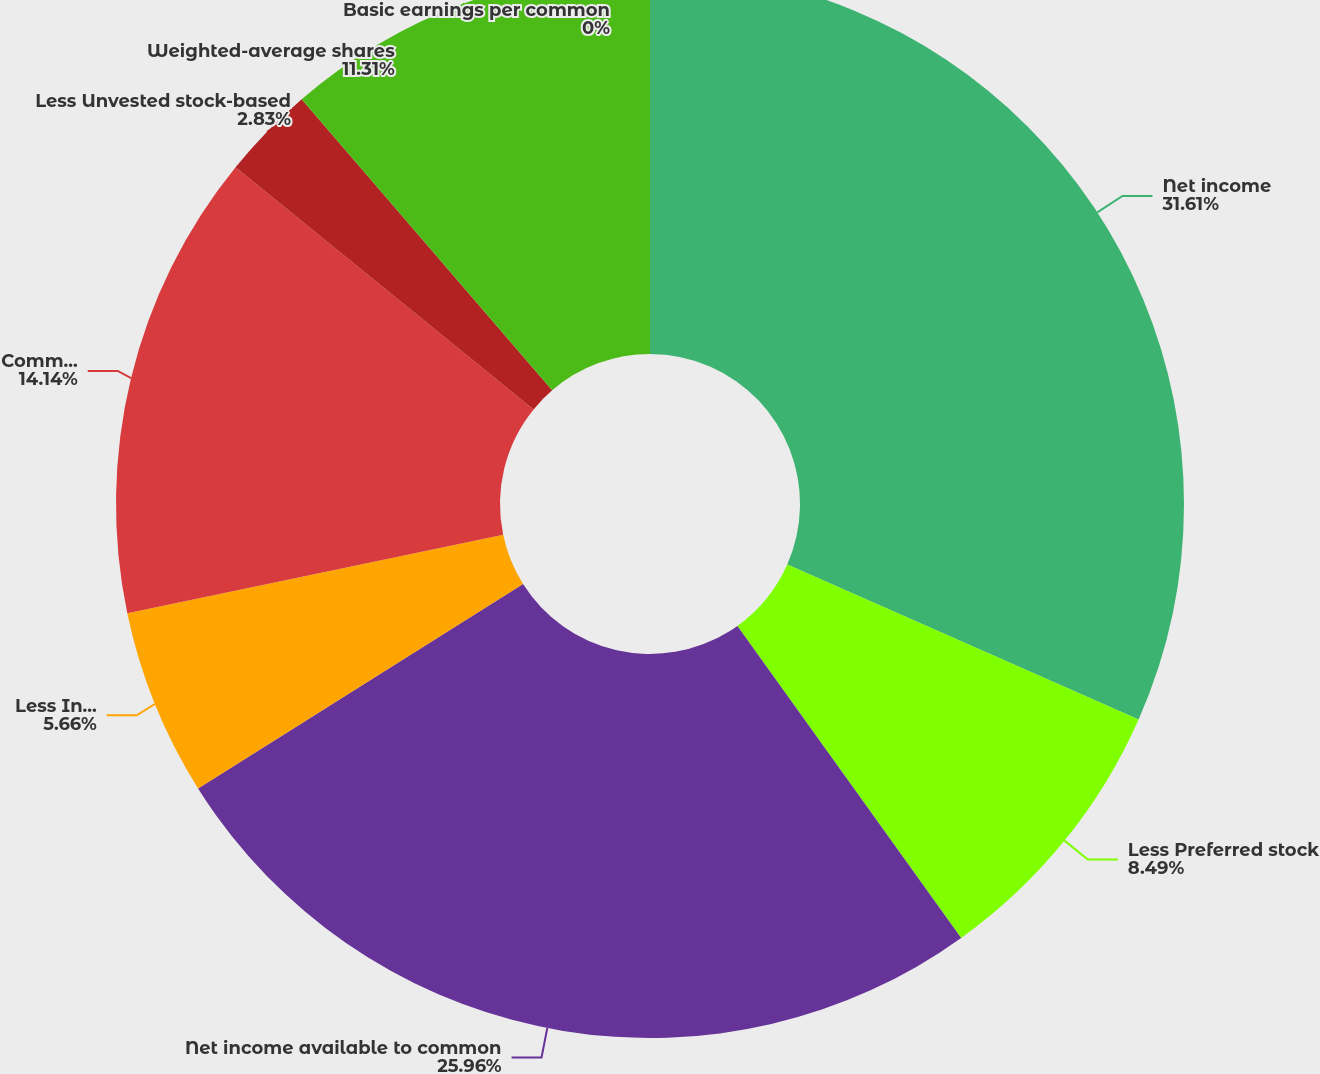Convert chart. <chart><loc_0><loc_0><loc_500><loc_500><pie_chart><fcel>Net income<fcel>Less Preferred stock<fcel>Net income available to common<fcel>Less Income attributable to<fcel>Common shares outstanding<fcel>Less Unvested stock-based<fcel>Weighted-average shares<fcel>Basic earnings per common<nl><fcel>31.61%<fcel>8.49%<fcel>25.96%<fcel>5.66%<fcel>14.14%<fcel>2.83%<fcel>11.31%<fcel>0.0%<nl></chart> 